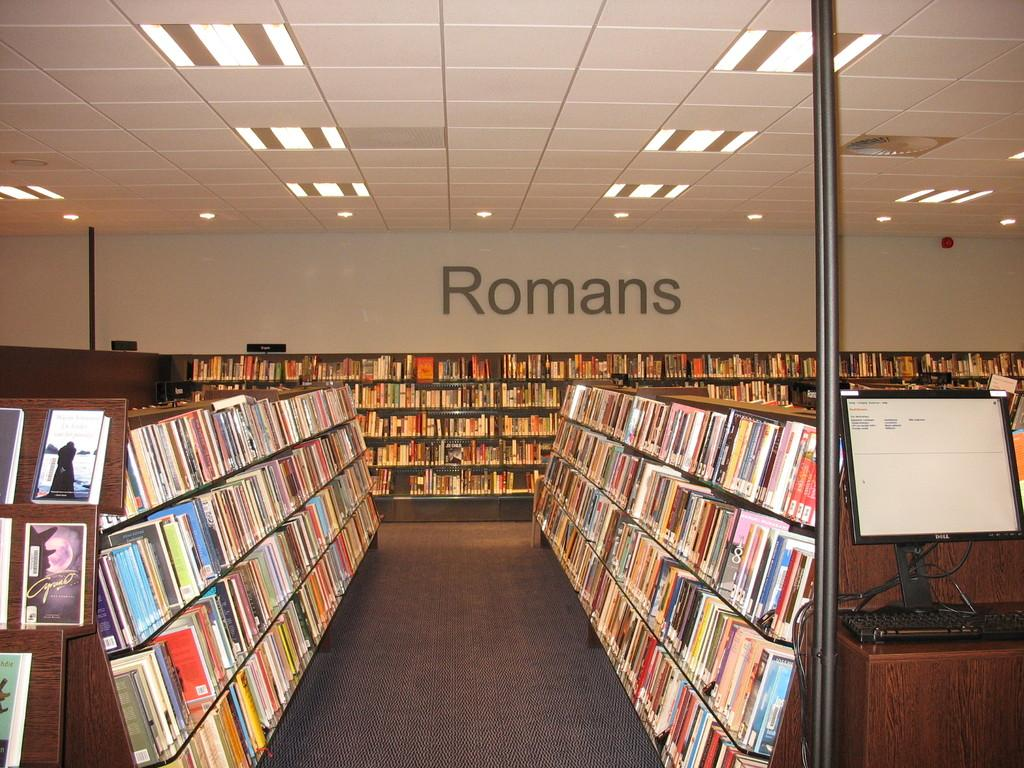Provide a one-sentence caption for the provided image. The inside of a library, the Romans category is seen ahead. 